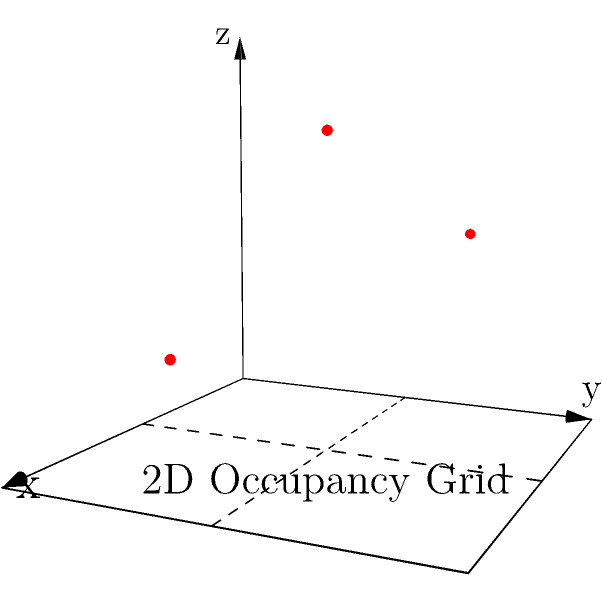Given a mobile robot equipped with a 3D sensor that captures data points in the form $(x, y, z)$, how would you map these points onto a 2D occupancy grid for navigation purposes? Consider the three red points in the 3D space above and describe a method to project them onto the 2D grid while preserving useful information for obstacle avoidance. To map 3D sensor data onto a 2D occupancy grid for mobile robot navigation, we can follow these steps:

1. Projection method:
   - Use orthographic projection to map 3D points onto the 2D plane.
   - In this case, we'll project onto the XY plane (z=0).

2. For each 3D point $(x, y, z)$:
   - The corresponding 2D point will be $(x, y)$.
   - Store the z-value as additional information in the grid cell.

3. Discretization:
   - Divide the 2D space into a grid of cells.
   - Each cell represents a discrete area in the robot's environment.

4. Occupancy representation:
   - For each projected point, mark the corresponding grid cell as occupied.
   - Store the maximum z-value of all points projecting to that cell.

5. Information preservation:
   - The stored z-value represents the height of the highest obstacle in that cell.
   - This helps in distinguishing between obstacles of different heights.

6. For the given points:
   - (1, 1, 1.5) projects to cell (1, 1) with height 1.5
   - (0.5, 1.5, 1) projects to cell (0, 1) with height 1
   - (1.5, 0.5, 0.5) projects to cell (1, 0) with height 0.5

7. Obstacle avoidance:
   - The robot can use the 2D grid for path planning.
   - The stored height information helps in determining if an obstacle can be passed under or must be fully avoided.

This method allows the robot to navigate in a 2D space while still considering the height of obstacles, crucial for effective obstacle avoidance in 3D environments.
Answer: Orthographic projection onto XY plane, storing maximum z-value per cell. 